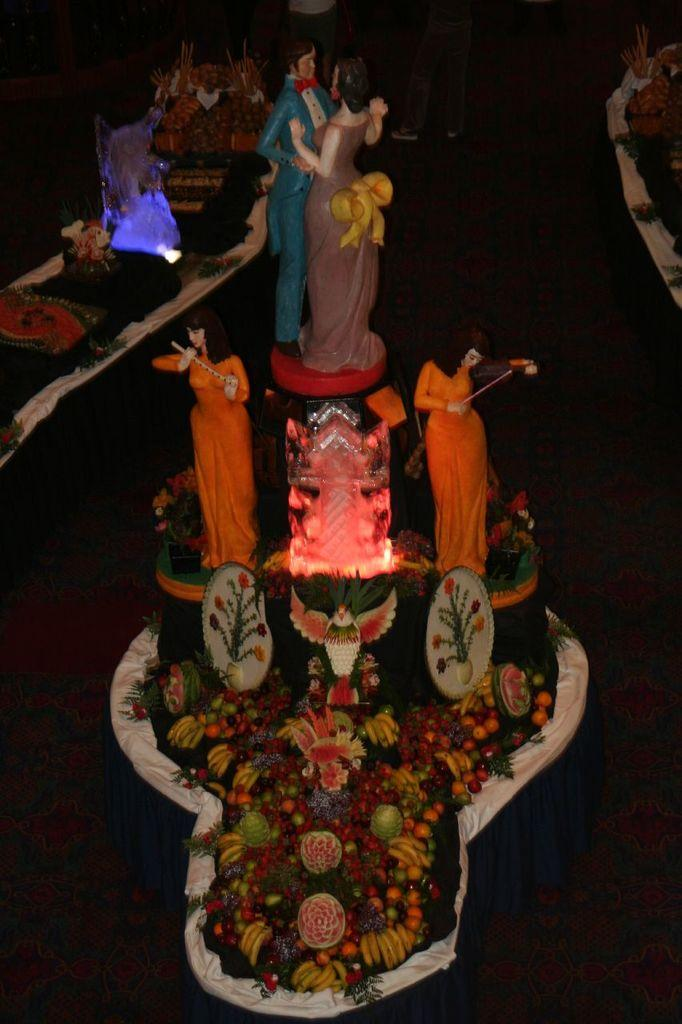What type of objects can be seen in the image? There are statues and fruits in the image. Can you describe the statues in the image? Unfortunately, the provided facts do not give any details about the statues, so we cannot describe them. What type of fruits are present in the image? The provided facts do not specify the type of fruits in the image, so we cannot describe them. Where is the cave located in the image? There is no cave present in the image. What type of meat is being served on the plate in the image? There is no meat or plate present in the image. 